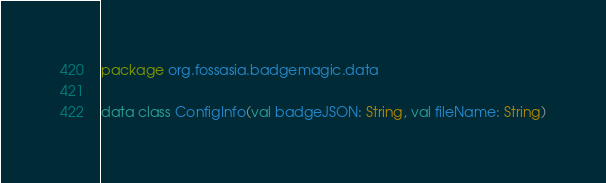Convert code to text. <code><loc_0><loc_0><loc_500><loc_500><_Kotlin_>package org.fossasia.badgemagic.data

data class ConfigInfo(val badgeJSON: String, val fileName: String)
</code> 